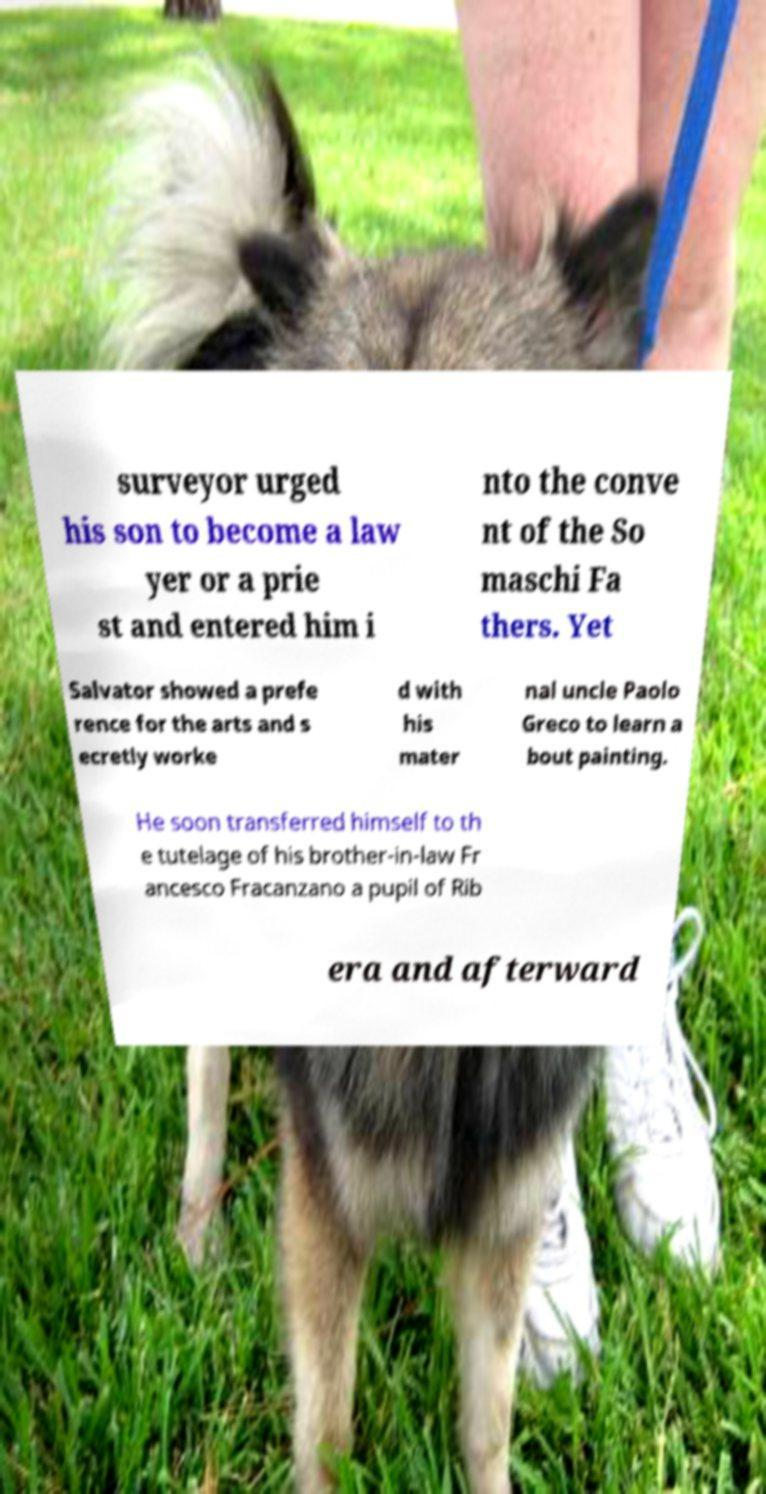What messages or text are displayed in this image? I need them in a readable, typed format. surveyor urged his son to become a law yer or a prie st and entered him i nto the conve nt of the So maschi Fa thers. Yet Salvator showed a prefe rence for the arts and s ecretly worke d with his mater nal uncle Paolo Greco to learn a bout painting. He soon transferred himself to th e tutelage of his brother-in-law Fr ancesco Fracanzano a pupil of Rib era and afterward 